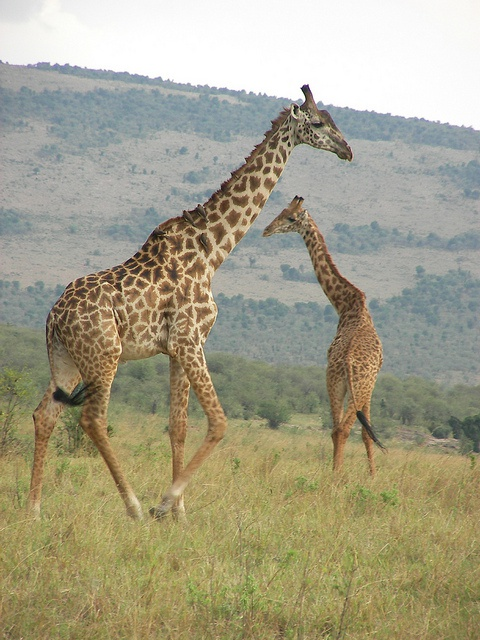Describe the objects in this image and their specific colors. I can see giraffe in lightgray, tan, gray, and maroon tones and giraffe in lightgray, gray, maroon, and tan tones in this image. 